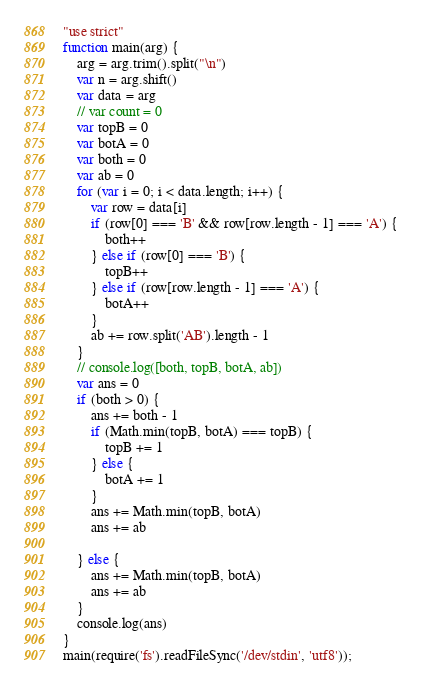<code> <loc_0><loc_0><loc_500><loc_500><_JavaScript_>"use strict"
function main(arg) {
    arg = arg.trim().split("\n")
    var n = arg.shift()
    var data = arg
    // var count = 0
    var topB = 0
    var botA = 0
    var both = 0
    var ab = 0
    for (var i = 0; i < data.length; i++) {
        var row = data[i]
        if (row[0] === 'B' && row[row.length - 1] === 'A') {
            both++
        } else if (row[0] === 'B') {
            topB++
        } else if (row[row.length - 1] === 'A') {
            botA++
        }
        ab += row.split('AB').length - 1
    }
    // console.log([both, topB, botA, ab])
    var ans = 0
    if (both > 0) {
        ans += both - 1
        if (Math.min(topB, botA) === topB) {
            topB += 1
        } else {
            botA += 1
        }
        ans += Math.min(topB, botA)
        ans += ab

    } else {
        ans += Math.min(topB, botA)
        ans += ab
    }
    console.log(ans)
}
main(require('fs').readFileSync('/dev/stdin', 'utf8'));</code> 